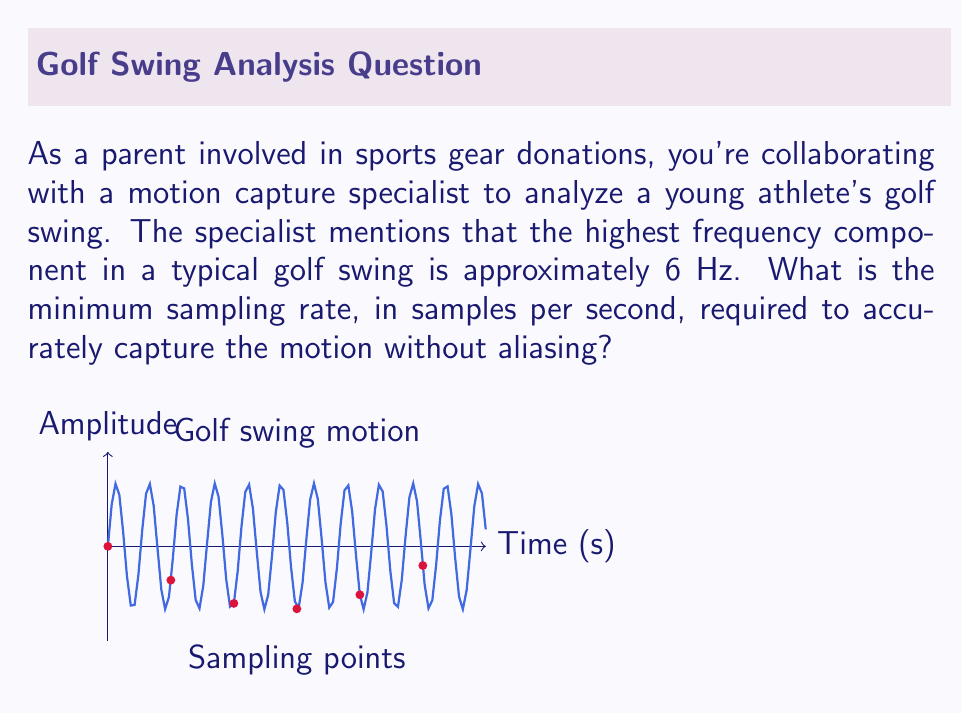Give your solution to this math problem. To determine the minimum sampling rate without aliasing, we need to apply the Nyquist-Shannon sampling theorem. This theorem states that to accurately reconstruct a continuous signal from discrete samples, the sampling rate must be at least twice the highest frequency component in the signal.

Step 1: Identify the highest frequency component
The highest frequency component in the golf swing is given as 6 Hz.

Step 2: Apply the Nyquist-Shannon sampling theorem
The minimum sampling rate ($$f_s$$) is calculated as:

$$f_s = 2 \cdot f_{max}$$

Where $$f_{max}$$ is the highest frequency component in the signal.

Step 3: Calculate the minimum sampling rate
$$f_s = 2 \cdot 6\text{ Hz} = 12\text{ Hz}$$

Step 4: Convert to samples per second
Since Hz is equivalent to samples per second, the minimum sampling rate is 12 samples per second.

This sampling rate ensures that we can accurately capture the golf swing motion without aliasing, which would result in a misrepresentation of the actual motion.
Answer: 12 samples per second 